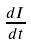<formula> <loc_0><loc_0><loc_500><loc_500>\frac { d I } { d t }</formula> 